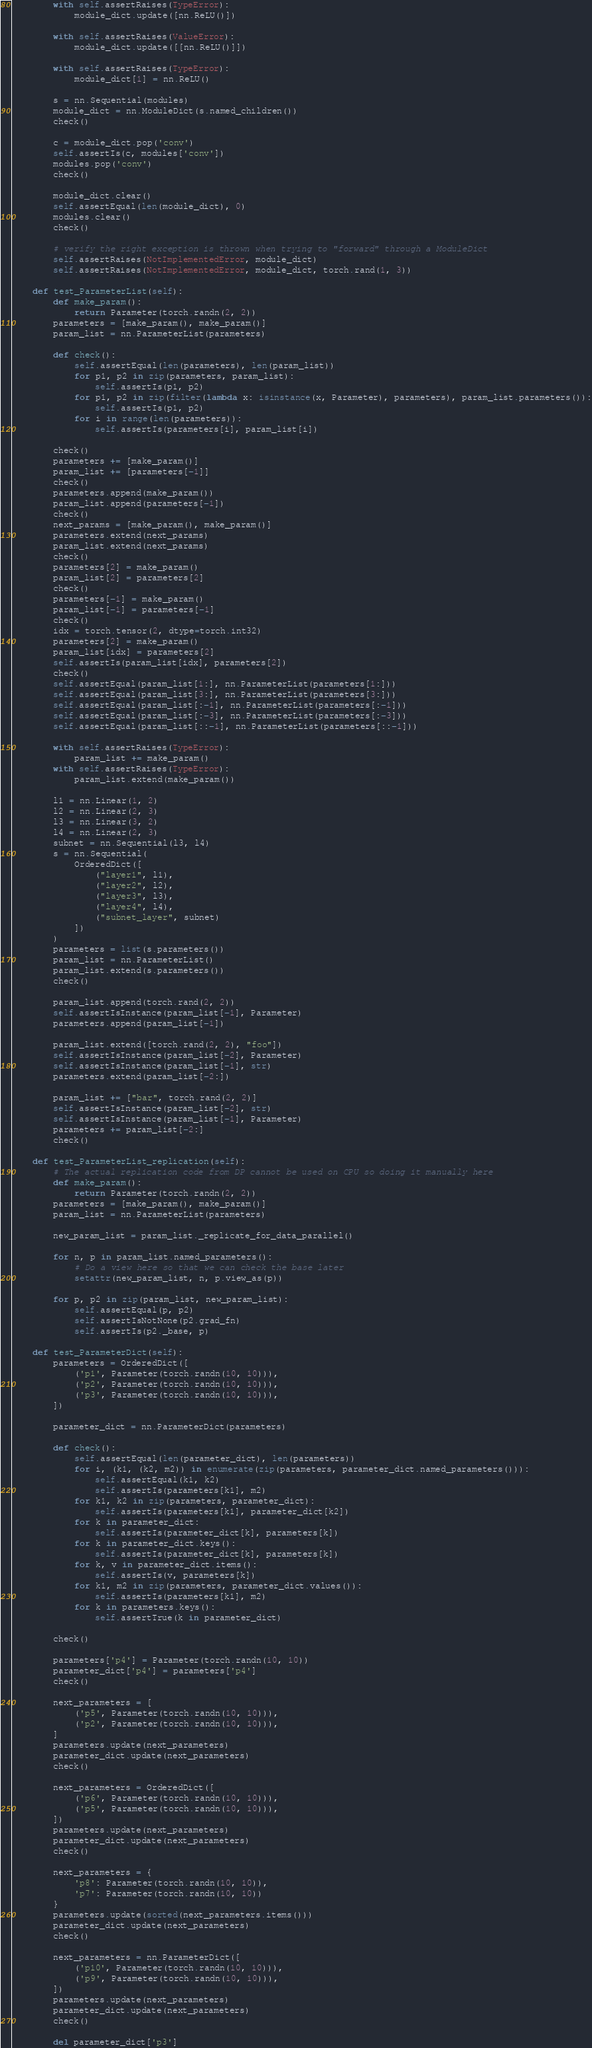<code> <loc_0><loc_0><loc_500><loc_500><_Python_>        with self.assertRaises(TypeError):
            module_dict.update([nn.ReLU()])

        with self.assertRaises(ValueError):
            module_dict.update([[nn.ReLU()]])

        with self.assertRaises(TypeError):
            module_dict[1] = nn.ReLU()

        s = nn.Sequential(modules)
        module_dict = nn.ModuleDict(s.named_children())
        check()

        c = module_dict.pop('conv')
        self.assertIs(c, modules['conv'])
        modules.pop('conv')
        check()

        module_dict.clear()
        self.assertEqual(len(module_dict), 0)
        modules.clear()
        check()

        # verify the right exception is thrown when trying to "forward" through a ModuleDict
        self.assertRaises(NotImplementedError, module_dict)
        self.assertRaises(NotImplementedError, module_dict, torch.rand(1, 3))

    def test_ParameterList(self):
        def make_param():
            return Parameter(torch.randn(2, 2))
        parameters = [make_param(), make_param()]
        param_list = nn.ParameterList(parameters)

        def check():
            self.assertEqual(len(parameters), len(param_list))
            for p1, p2 in zip(parameters, param_list):
                self.assertIs(p1, p2)
            for p1, p2 in zip(filter(lambda x: isinstance(x, Parameter), parameters), param_list.parameters()):
                self.assertIs(p1, p2)
            for i in range(len(parameters)):
                self.assertIs(parameters[i], param_list[i])

        check()
        parameters += [make_param()]
        param_list += [parameters[-1]]
        check()
        parameters.append(make_param())
        param_list.append(parameters[-1])
        check()
        next_params = [make_param(), make_param()]
        parameters.extend(next_params)
        param_list.extend(next_params)
        check()
        parameters[2] = make_param()
        param_list[2] = parameters[2]
        check()
        parameters[-1] = make_param()
        param_list[-1] = parameters[-1]
        check()
        idx = torch.tensor(2, dtype=torch.int32)
        parameters[2] = make_param()
        param_list[idx] = parameters[2]
        self.assertIs(param_list[idx], parameters[2])
        check()
        self.assertEqual(param_list[1:], nn.ParameterList(parameters[1:]))
        self.assertEqual(param_list[3:], nn.ParameterList(parameters[3:]))
        self.assertEqual(param_list[:-1], nn.ParameterList(parameters[:-1]))
        self.assertEqual(param_list[:-3], nn.ParameterList(parameters[:-3]))
        self.assertEqual(param_list[::-1], nn.ParameterList(parameters[::-1]))

        with self.assertRaises(TypeError):
            param_list += make_param()
        with self.assertRaises(TypeError):
            param_list.extend(make_param())

        l1 = nn.Linear(1, 2)
        l2 = nn.Linear(2, 3)
        l3 = nn.Linear(3, 2)
        l4 = nn.Linear(2, 3)
        subnet = nn.Sequential(l3, l4)
        s = nn.Sequential(
            OrderedDict([
                ("layer1", l1),
                ("layer2", l2),
                ("layer3", l3),
                ("layer4", l4),
                ("subnet_layer", subnet)
            ])
        )
        parameters = list(s.parameters())
        param_list = nn.ParameterList()
        param_list.extend(s.parameters())
        check()

        param_list.append(torch.rand(2, 2))
        self.assertIsInstance(param_list[-1], Parameter)
        parameters.append(param_list[-1])

        param_list.extend([torch.rand(2, 2), "foo"])
        self.assertIsInstance(param_list[-2], Parameter)
        self.assertIsInstance(param_list[-1], str)
        parameters.extend(param_list[-2:])

        param_list += ["bar", torch.rand(2, 2)]
        self.assertIsInstance(param_list[-2], str)
        self.assertIsInstance(param_list[-1], Parameter)
        parameters += param_list[-2:]
        check()

    def test_ParameterList_replication(self):
        # The actual replication code from DP cannot be used on CPU so doing it manually here
        def make_param():
            return Parameter(torch.randn(2, 2))
        parameters = [make_param(), make_param()]
        param_list = nn.ParameterList(parameters)

        new_param_list = param_list._replicate_for_data_parallel()

        for n, p in param_list.named_parameters():
            # Do a view here so that we can check the base later
            setattr(new_param_list, n, p.view_as(p))

        for p, p2 in zip(param_list, new_param_list):
            self.assertEqual(p, p2)
            self.assertIsNotNone(p2.grad_fn)
            self.assertIs(p2._base, p)

    def test_ParameterDict(self):
        parameters = OrderedDict([
            ('p1', Parameter(torch.randn(10, 10))),
            ('p2', Parameter(torch.randn(10, 10))),
            ('p3', Parameter(torch.randn(10, 10))),
        ])

        parameter_dict = nn.ParameterDict(parameters)

        def check():
            self.assertEqual(len(parameter_dict), len(parameters))
            for i, (k1, (k2, m2)) in enumerate(zip(parameters, parameter_dict.named_parameters())):
                self.assertEqual(k1, k2)
                self.assertIs(parameters[k1], m2)
            for k1, k2 in zip(parameters, parameter_dict):
                self.assertIs(parameters[k1], parameter_dict[k2])
            for k in parameter_dict:
                self.assertIs(parameter_dict[k], parameters[k])
            for k in parameter_dict.keys():
                self.assertIs(parameter_dict[k], parameters[k])
            for k, v in parameter_dict.items():
                self.assertIs(v, parameters[k])
            for k1, m2 in zip(parameters, parameter_dict.values()):
                self.assertIs(parameters[k1], m2)
            for k in parameters.keys():
                self.assertTrue(k in parameter_dict)

        check()

        parameters['p4'] = Parameter(torch.randn(10, 10))
        parameter_dict['p4'] = parameters['p4']
        check()

        next_parameters = [
            ('p5', Parameter(torch.randn(10, 10))),
            ('p2', Parameter(torch.randn(10, 10))),
        ]
        parameters.update(next_parameters)
        parameter_dict.update(next_parameters)
        check()

        next_parameters = OrderedDict([
            ('p6', Parameter(torch.randn(10, 10))),
            ('p5', Parameter(torch.randn(10, 10))),
        ])
        parameters.update(next_parameters)
        parameter_dict.update(next_parameters)
        check()

        next_parameters = {
            'p8': Parameter(torch.randn(10, 10)),
            'p7': Parameter(torch.randn(10, 10))
        }
        parameters.update(sorted(next_parameters.items()))
        parameter_dict.update(next_parameters)
        check()

        next_parameters = nn.ParameterDict([
            ('p10', Parameter(torch.randn(10, 10))),
            ('p9', Parameter(torch.randn(10, 10))),
        ])
        parameters.update(next_parameters)
        parameter_dict.update(next_parameters)
        check()

        del parameter_dict['p3']</code> 